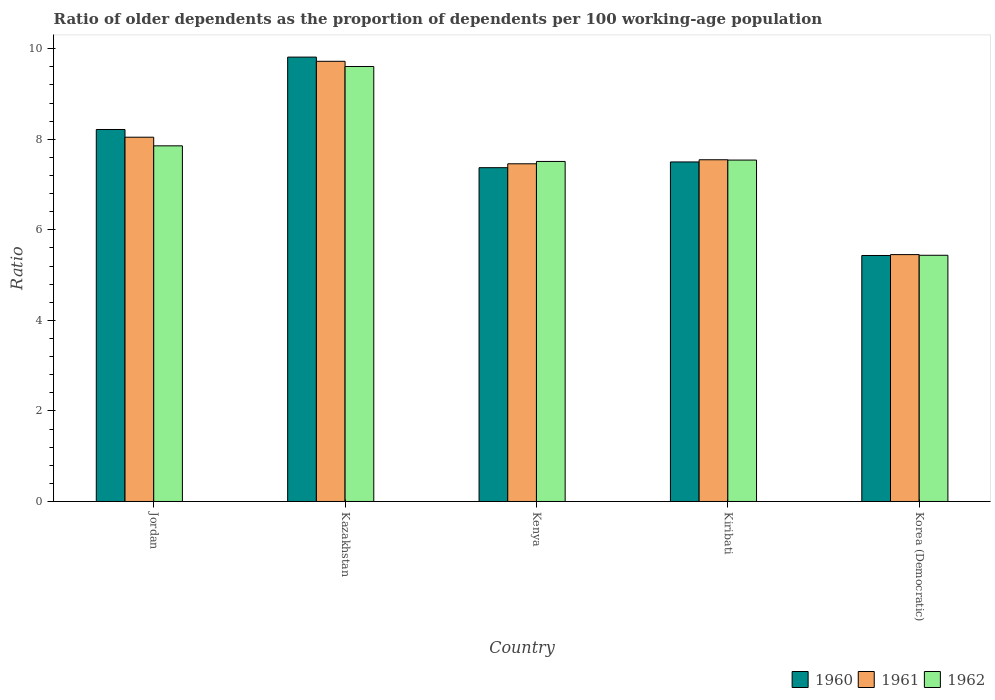How many different coloured bars are there?
Ensure brevity in your answer.  3. Are the number of bars on each tick of the X-axis equal?
Provide a short and direct response. Yes. What is the label of the 5th group of bars from the left?
Ensure brevity in your answer.  Korea (Democratic). In how many cases, is the number of bars for a given country not equal to the number of legend labels?
Ensure brevity in your answer.  0. What is the age dependency ratio(old) in 1962 in Jordan?
Give a very brief answer. 7.85. Across all countries, what is the maximum age dependency ratio(old) in 1962?
Give a very brief answer. 9.61. Across all countries, what is the minimum age dependency ratio(old) in 1961?
Provide a succinct answer. 5.45. In which country was the age dependency ratio(old) in 1962 maximum?
Offer a very short reply. Kazakhstan. In which country was the age dependency ratio(old) in 1962 minimum?
Ensure brevity in your answer.  Korea (Democratic). What is the total age dependency ratio(old) in 1962 in the graph?
Ensure brevity in your answer.  37.95. What is the difference between the age dependency ratio(old) in 1960 in Jordan and that in Kazakhstan?
Provide a succinct answer. -1.6. What is the difference between the age dependency ratio(old) in 1960 in Jordan and the age dependency ratio(old) in 1962 in Kazakhstan?
Your answer should be very brief. -1.39. What is the average age dependency ratio(old) in 1961 per country?
Ensure brevity in your answer.  7.64. What is the difference between the age dependency ratio(old) of/in 1962 and age dependency ratio(old) of/in 1960 in Kiribati?
Keep it short and to the point. 0.04. What is the ratio of the age dependency ratio(old) in 1961 in Kenya to that in Korea (Democratic)?
Offer a very short reply. 1.37. What is the difference between the highest and the second highest age dependency ratio(old) in 1960?
Provide a short and direct response. -1.6. What is the difference between the highest and the lowest age dependency ratio(old) in 1962?
Offer a terse response. 4.17. In how many countries, is the age dependency ratio(old) in 1961 greater than the average age dependency ratio(old) in 1961 taken over all countries?
Give a very brief answer. 2. Is the sum of the age dependency ratio(old) in 1960 in Kenya and Korea (Democratic) greater than the maximum age dependency ratio(old) in 1961 across all countries?
Provide a short and direct response. Yes. What does the 2nd bar from the left in Kenya represents?
Your response must be concise. 1961. What does the 2nd bar from the right in Jordan represents?
Your answer should be very brief. 1961. How many bars are there?
Your answer should be compact. 15. Are all the bars in the graph horizontal?
Your answer should be very brief. No. What is the difference between two consecutive major ticks on the Y-axis?
Your answer should be compact. 2. Are the values on the major ticks of Y-axis written in scientific E-notation?
Your answer should be compact. No. Does the graph contain any zero values?
Offer a terse response. No. Where does the legend appear in the graph?
Offer a very short reply. Bottom right. What is the title of the graph?
Offer a very short reply. Ratio of older dependents as the proportion of dependents per 100 working-age population. Does "2010" appear as one of the legend labels in the graph?
Ensure brevity in your answer.  No. What is the label or title of the X-axis?
Your answer should be very brief. Country. What is the label or title of the Y-axis?
Your answer should be compact. Ratio. What is the Ratio in 1960 in Jordan?
Provide a succinct answer. 8.22. What is the Ratio of 1961 in Jordan?
Ensure brevity in your answer.  8.04. What is the Ratio of 1962 in Jordan?
Give a very brief answer. 7.85. What is the Ratio in 1960 in Kazakhstan?
Offer a terse response. 9.81. What is the Ratio in 1961 in Kazakhstan?
Provide a short and direct response. 9.72. What is the Ratio of 1962 in Kazakhstan?
Your answer should be very brief. 9.61. What is the Ratio in 1960 in Kenya?
Your response must be concise. 7.37. What is the Ratio of 1961 in Kenya?
Provide a succinct answer. 7.46. What is the Ratio in 1962 in Kenya?
Your response must be concise. 7.51. What is the Ratio of 1960 in Kiribati?
Provide a short and direct response. 7.5. What is the Ratio in 1961 in Kiribati?
Offer a terse response. 7.55. What is the Ratio of 1962 in Kiribati?
Keep it short and to the point. 7.54. What is the Ratio of 1960 in Korea (Democratic)?
Provide a short and direct response. 5.43. What is the Ratio of 1961 in Korea (Democratic)?
Keep it short and to the point. 5.45. What is the Ratio of 1962 in Korea (Democratic)?
Your answer should be very brief. 5.44. Across all countries, what is the maximum Ratio in 1960?
Make the answer very short. 9.81. Across all countries, what is the maximum Ratio in 1961?
Provide a succinct answer. 9.72. Across all countries, what is the maximum Ratio in 1962?
Your answer should be compact. 9.61. Across all countries, what is the minimum Ratio in 1960?
Offer a terse response. 5.43. Across all countries, what is the minimum Ratio of 1961?
Offer a very short reply. 5.45. Across all countries, what is the minimum Ratio in 1962?
Your response must be concise. 5.44. What is the total Ratio of 1960 in the graph?
Give a very brief answer. 38.33. What is the total Ratio in 1961 in the graph?
Keep it short and to the point. 38.22. What is the total Ratio in 1962 in the graph?
Your response must be concise. 37.95. What is the difference between the Ratio of 1960 in Jordan and that in Kazakhstan?
Make the answer very short. -1.6. What is the difference between the Ratio in 1961 in Jordan and that in Kazakhstan?
Keep it short and to the point. -1.68. What is the difference between the Ratio in 1962 in Jordan and that in Kazakhstan?
Make the answer very short. -1.75. What is the difference between the Ratio in 1960 in Jordan and that in Kenya?
Offer a very short reply. 0.84. What is the difference between the Ratio of 1961 in Jordan and that in Kenya?
Provide a short and direct response. 0.59. What is the difference between the Ratio of 1962 in Jordan and that in Kenya?
Keep it short and to the point. 0.34. What is the difference between the Ratio in 1960 in Jordan and that in Kiribati?
Make the answer very short. 0.72. What is the difference between the Ratio of 1961 in Jordan and that in Kiribati?
Your answer should be very brief. 0.5. What is the difference between the Ratio in 1962 in Jordan and that in Kiribati?
Your answer should be very brief. 0.31. What is the difference between the Ratio in 1960 in Jordan and that in Korea (Democratic)?
Make the answer very short. 2.78. What is the difference between the Ratio of 1961 in Jordan and that in Korea (Democratic)?
Offer a terse response. 2.59. What is the difference between the Ratio in 1962 in Jordan and that in Korea (Democratic)?
Your answer should be very brief. 2.42. What is the difference between the Ratio of 1960 in Kazakhstan and that in Kenya?
Your answer should be compact. 2.44. What is the difference between the Ratio of 1961 in Kazakhstan and that in Kenya?
Offer a terse response. 2.26. What is the difference between the Ratio in 1962 in Kazakhstan and that in Kenya?
Make the answer very short. 2.1. What is the difference between the Ratio in 1960 in Kazakhstan and that in Kiribati?
Provide a short and direct response. 2.32. What is the difference between the Ratio of 1961 in Kazakhstan and that in Kiribati?
Give a very brief answer. 2.17. What is the difference between the Ratio in 1962 in Kazakhstan and that in Kiribati?
Your response must be concise. 2.07. What is the difference between the Ratio in 1960 in Kazakhstan and that in Korea (Democratic)?
Give a very brief answer. 4.38. What is the difference between the Ratio of 1961 in Kazakhstan and that in Korea (Democratic)?
Your answer should be very brief. 4.27. What is the difference between the Ratio of 1962 in Kazakhstan and that in Korea (Democratic)?
Give a very brief answer. 4.17. What is the difference between the Ratio of 1960 in Kenya and that in Kiribati?
Offer a very short reply. -0.13. What is the difference between the Ratio of 1961 in Kenya and that in Kiribati?
Give a very brief answer. -0.09. What is the difference between the Ratio in 1962 in Kenya and that in Kiribati?
Your answer should be compact. -0.03. What is the difference between the Ratio in 1960 in Kenya and that in Korea (Democratic)?
Your answer should be compact. 1.94. What is the difference between the Ratio in 1961 in Kenya and that in Korea (Democratic)?
Keep it short and to the point. 2.01. What is the difference between the Ratio of 1962 in Kenya and that in Korea (Democratic)?
Your response must be concise. 2.07. What is the difference between the Ratio of 1960 in Kiribati and that in Korea (Democratic)?
Your answer should be very brief. 2.07. What is the difference between the Ratio in 1961 in Kiribati and that in Korea (Democratic)?
Your response must be concise. 2.09. What is the difference between the Ratio of 1962 in Kiribati and that in Korea (Democratic)?
Your response must be concise. 2.1. What is the difference between the Ratio of 1960 in Jordan and the Ratio of 1961 in Kazakhstan?
Your answer should be compact. -1.51. What is the difference between the Ratio in 1960 in Jordan and the Ratio in 1962 in Kazakhstan?
Keep it short and to the point. -1.39. What is the difference between the Ratio of 1961 in Jordan and the Ratio of 1962 in Kazakhstan?
Provide a succinct answer. -1.56. What is the difference between the Ratio of 1960 in Jordan and the Ratio of 1961 in Kenya?
Keep it short and to the point. 0.76. What is the difference between the Ratio of 1960 in Jordan and the Ratio of 1962 in Kenya?
Your answer should be very brief. 0.71. What is the difference between the Ratio of 1961 in Jordan and the Ratio of 1962 in Kenya?
Keep it short and to the point. 0.54. What is the difference between the Ratio of 1960 in Jordan and the Ratio of 1961 in Kiribati?
Provide a short and direct response. 0.67. What is the difference between the Ratio in 1960 in Jordan and the Ratio in 1962 in Kiribati?
Make the answer very short. 0.68. What is the difference between the Ratio in 1961 in Jordan and the Ratio in 1962 in Kiribati?
Your answer should be compact. 0.5. What is the difference between the Ratio of 1960 in Jordan and the Ratio of 1961 in Korea (Democratic)?
Your response must be concise. 2.76. What is the difference between the Ratio of 1960 in Jordan and the Ratio of 1962 in Korea (Democratic)?
Keep it short and to the point. 2.78. What is the difference between the Ratio of 1961 in Jordan and the Ratio of 1962 in Korea (Democratic)?
Give a very brief answer. 2.61. What is the difference between the Ratio in 1960 in Kazakhstan and the Ratio in 1961 in Kenya?
Provide a short and direct response. 2.36. What is the difference between the Ratio in 1960 in Kazakhstan and the Ratio in 1962 in Kenya?
Your answer should be compact. 2.3. What is the difference between the Ratio of 1961 in Kazakhstan and the Ratio of 1962 in Kenya?
Keep it short and to the point. 2.21. What is the difference between the Ratio of 1960 in Kazakhstan and the Ratio of 1961 in Kiribati?
Your answer should be very brief. 2.27. What is the difference between the Ratio of 1960 in Kazakhstan and the Ratio of 1962 in Kiribati?
Your response must be concise. 2.27. What is the difference between the Ratio in 1961 in Kazakhstan and the Ratio in 1962 in Kiribati?
Make the answer very short. 2.18. What is the difference between the Ratio of 1960 in Kazakhstan and the Ratio of 1961 in Korea (Democratic)?
Your answer should be very brief. 4.36. What is the difference between the Ratio in 1960 in Kazakhstan and the Ratio in 1962 in Korea (Democratic)?
Your response must be concise. 4.38. What is the difference between the Ratio of 1961 in Kazakhstan and the Ratio of 1962 in Korea (Democratic)?
Provide a succinct answer. 4.28. What is the difference between the Ratio in 1960 in Kenya and the Ratio in 1961 in Kiribati?
Give a very brief answer. -0.17. What is the difference between the Ratio of 1960 in Kenya and the Ratio of 1962 in Kiribati?
Your answer should be compact. -0.17. What is the difference between the Ratio in 1961 in Kenya and the Ratio in 1962 in Kiribati?
Ensure brevity in your answer.  -0.08. What is the difference between the Ratio in 1960 in Kenya and the Ratio in 1961 in Korea (Democratic)?
Offer a very short reply. 1.92. What is the difference between the Ratio of 1960 in Kenya and the Ratio of 1962 in Korea (Democratic)?
Your answer should be compact. 1.93. What is the difference between the Ratio in 1961 in Kenya and the Ratio in 1962 in Korea (Democratic)?
Offer a terse response. 2.02. What is the difference between the Ratio in 1960 in Kiribati and the Ratio in 1961 in Korea (Democratic)?
Offer a very short reply. 2.05. What is the difference between the Ratio of 1960 in Kiribati and the Ratio of 1962 in Korea (Democratic)?
Ensure brevity in your answer.  2.06. What is the difference between the Ratio of 1961 in Kiribati and the Ratio of 1962 in Korea (Democratic)?
Give a very brief answer. 2.11. What is the average Ratio in 1960 per country?
Your response must be concise. 7.67. What is the average Ratio in 1961 per country?
Your answer should be very brief. 7.64. What is the average Ratio in 1962 per country?
Provide a short and direct response. 7.59. What is the difference between the Ratio in 1960 and Ratio in 1961 in Jordan?
Ensure brevity in your answer.  0.17. What is the difference between the Ratio in 1960 and Ratio in 1962 in Jordan?
Provide a short and direct response. 0.36. What is the difference between the Ratio in 1961 and Ratio in 1962 in Jordan?
Make the answer very short. 0.19. What is the difference between the Ratio of 1960 and Ratio of 1961 in Kazakhstan?
Keep it short and to the point. 0.09. What is the difference between the Ratio in 1960 and Ratio in 1962 in Kazakhstan?
Keep it short and to the point. 0.21. What is the difference between the Ratio of 1961 and Ratio of 1962 in Kazakhstan?
Keep it short and to the point. 0.11. What is the difference between the Ratio in 1960 and Ratio in 1961 in Kenya?
Provide a succinct answer. -0.09. What is the difference between the Ratio of 1960 and Ratio of 1962 in Kenya?
Provide a succinct answer. -0.14. What is the difference between the Ratio in 1961 and Ratio in 1962 in Kenya?
Your answer should be compact. -0.05. What is the difference between the Ratio in 1960 and Ratio in 1961 in Kiribati?
Your response must be concise. -0.05. What is the difference between the Ratio in 1960 and Ratio in 1962 in Kiribati?
Your answer should be very brief. -0.04. What is the difference between the Ratio in 1961 and Ratio in 1962 in Kiribati?
Your answer should be compact. 0.01. What is the difference between the Ratio of 1960 and Ratio of 1961 in Korea (Democratic)?
Ensure brevity in your answer.  -0.02. What is the difference between the Ratio in 1960 and Ratio in 1962 in Korea (Democratic)?
Your answer should be compact. -0. What is the difference between the Ratio of 1961 and Ratio of 1962 in Korea (Democratic)?
Give a very brief answer. 0.01. What is the ratio of the Ratio in 1960 in Jordan to that in Kazakhstan?
Your answer should be compact. 0.84. What is the ratio of the Ratio in 1961 in Jordan to that in Kazakhstan?
Keep it short and to the point. 0.83. What is the ratio of the Ratio of 1962 in Jordan to that in Kazakhstan?
Provide a succinct answer. 0.82. What is the ratio of the Ratio in 1960 in Jordan to that in Kenya?
Offer a terse response. 1.11. What is the ratio of the Ratio of 1961 in Jordan to that in Kenya?
Your response must be concise. 1.08. What is the ratio of the Ratio of 1962 in Jordan to that in Kenya?
Keep it short and to the point. 1.05. What is the ratio of the Ratio of 1960 in Jordan to that in Kiribati?
Provide a short and direct response. 1.1. What is the ratio of the Ratio of 1961 in Jordan to that in Kiribati?
Offer a very short reply. 1.07. What is the ratio of the Ratio in 1962 in Jordan to that in Kiribati?
Ensure brevity in your answer.  1.04. What is the ratio of the Ratio in 1960 in Jordan to that in Korea (Democratic)?
Give a very brief answer. 1.51. What is the ratio of the Ratio in 1961 in Jordan to that in Korea (Democratic)?
Provide a succinct answer. 1.48. What is the ratio of the Ratio in 1962 in Jordan to that in Korea (Democratic)?
Provide a short and direct response. 1.44. What is the ratio of the Ratio in 1960 in Kazakhstan to that in Kenya?
Provide a short and direct response. 1.33. What is the ratio of the Ratio of 1961 in Kazakhstan to that in Kenya?
Give a very brief answer. 1.3. What is the ratio of the Ratio of 1962 in Kazakhstan to that in Kenya?
Make the answer very short. 1.28. What is the ratio of the Ratio of 1960 in Kazakhstan to that in Kiribati?
Your answer should be compact. 1.31. What is the ratio of the Ratio in 1961 in Kazakhstan to that in Kiribati?
Make the answer very short. 1.29. What is the ratio of the Ratio of 1962 in Kazakhstan to that in Kiribati?
Give a very brief answer. 1.27. What is the ratio of the Ratio of 1960 in Kazakhstan to that in Korea (Democratic)?
Offer a very short reply. 1.81. What is the ratio of the Ratio of 1961 in Kazakhstan to that in Korea (Democratic)?
Keep it short and to the point. 1.78. What is the ratio of the Ratio of 1962 in Kazakhstan to that in Korea (Democratic)?
Make the answer very short. 1.77. What is the ratio of the Ratio in 1960 in Kenya to that in Kiribati?
Your answer should be compact. 0.98. What is the ratio of the Ratio of 1960 in Kenya to that in Korea (Democratic)?
Provide a succinct answer. 1.36. What is the ratio of the Ratio of 1961 in Kenya to that in Korea (Democratic)?
Offer a terse response. 1.37. What is the ratio of the Ratio in 1962 in Kenya to that in Korea (Democratic)?
Provide a short and direct response. 1.38. What is the ratio of the Ratio in 1960 in Kiribati to that in Korea (Democratic)?
Make the answer very short. 1.38. What is the ratio of the Ratio in 1961 in Kiribati to that in Korea (Democratic)?
Offer a very short reply. 1.38. What is the ratio of the Ratio of 1962 in Kiribati to that in Korea (Democratic)?
Keep it short and to the point. 1.39. What is the difference between the highest and the second highest Ratio of 1960?
Make the answer very short. 1.6. What is the difference between the highest and the second highest Ratio in 1961?
Give a very brief answer. 1.68. What is the difference between the highest and the second highest Ratio of 1962?
Your response must be concise. 1.75. What is the difference between the highest and the lowest Ratio of 1960?
Offer a very short reply. 4.38. What is the difference between the highest and the lowest Ratio of 1961?
Your response must be concise. 4.27. What is the difference between the highest and the lowest Ratio in 1962?
Provide a short and direct response. 4.17. 